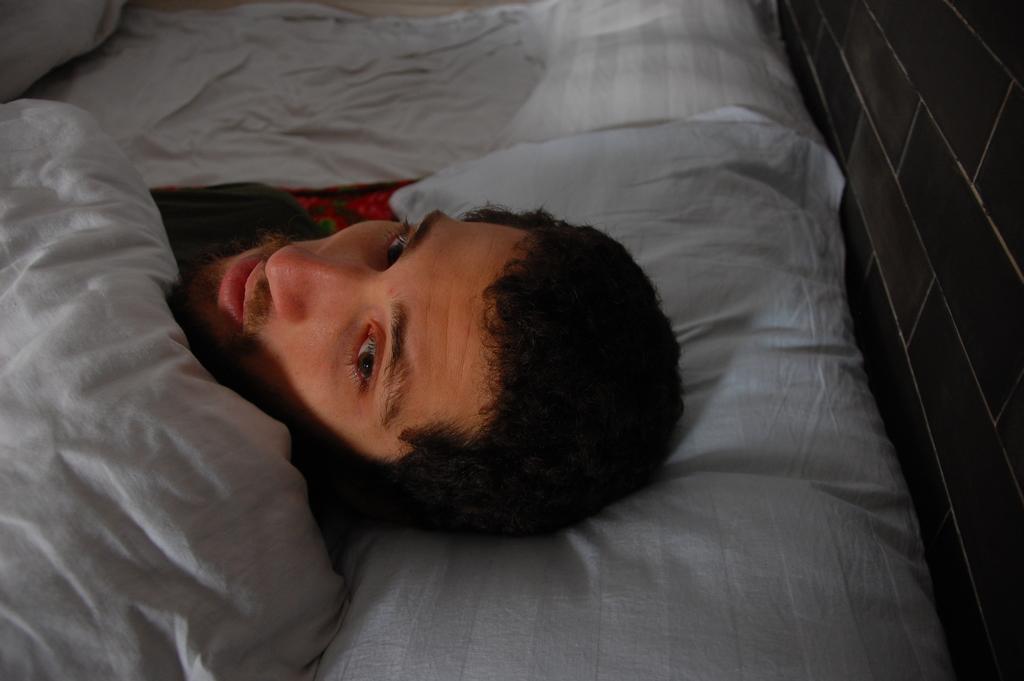Can you describe this image briefly? a person is sleeping with blanket on him 